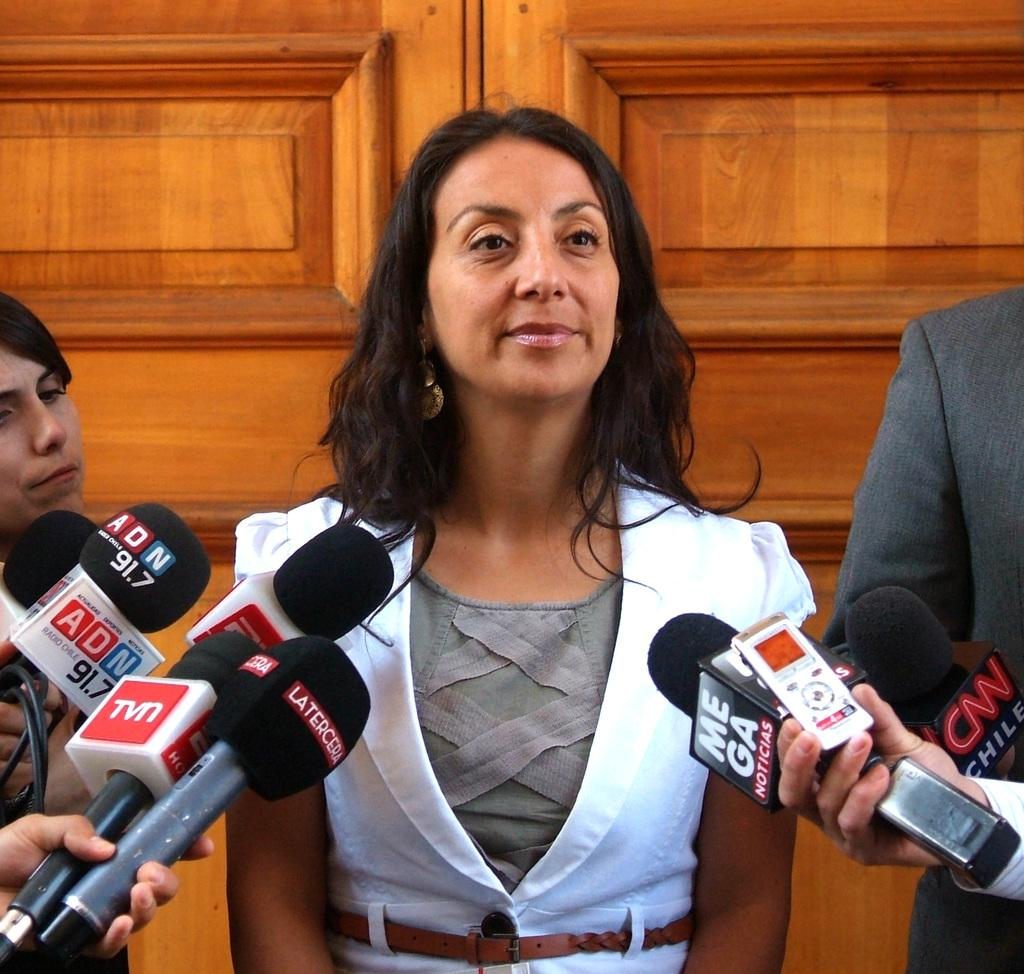Who is the main subject in the image? There is a girl in the image. What is the girl doing in the image? The girl is standing with a smile. What objects are held by other persons in front of the girl? There are microphones held by other persons in front of the girl. What can be seen in the background of the image? There is a wooden wall in the background of the image. How many bears are visible in the image? There are no bears present in the image. What is the girl doing with her thumb in the image? The girl is not shown doing anything with her thumb in the image. 